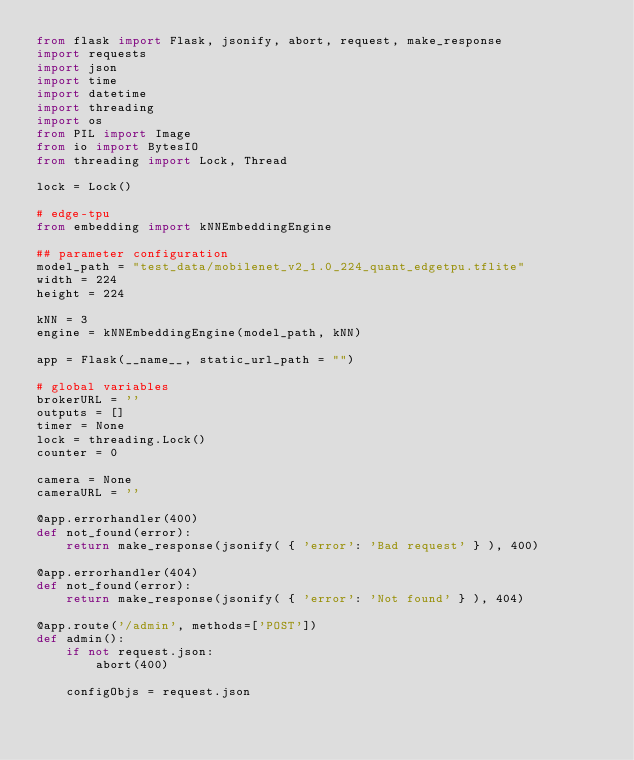<code> <loc_0><loc_0><loc_500><loc_500><_Python_>from flask import Flask, jsonify, abort, request, make_response
import requests 
import json
import time
import datetime
import threading
import os
from PIL import Image
from io import BytesIO
from threading import Lock, Thread

lock = Lock()

# edge-tpu
from embedding import kNNEmbeddingEngine

## parameter configuration
model_path = "test_data/mobilenet_v2_1.0_224_quant_edgetpu.tflite"
width = 224
height = 224

kNN = 3
engine = kNNEmbeddingEngine(model_path, kNN)

app = Flask(__name__, static_url_path = "")

# global variables
brokerURL = ''
outputs = []
timer = None
lock = threading.Lock()
counter = 0 

camera = None
cameraURL = ''

@app.errorhandler(400)
def not_found(error):
    return make_response(jsonify( { 'error': 'Bad request' } ), 400)

@app.errorhandler(404)
def not_found(error):
    return make_response(jsonify( { 'error': 'Not found' } ), 404)

@app.route('/admin', methods=['POST'])
def admin():    
    if not request.json:
        abort(400)
    
    configObjs = request.json</code> 